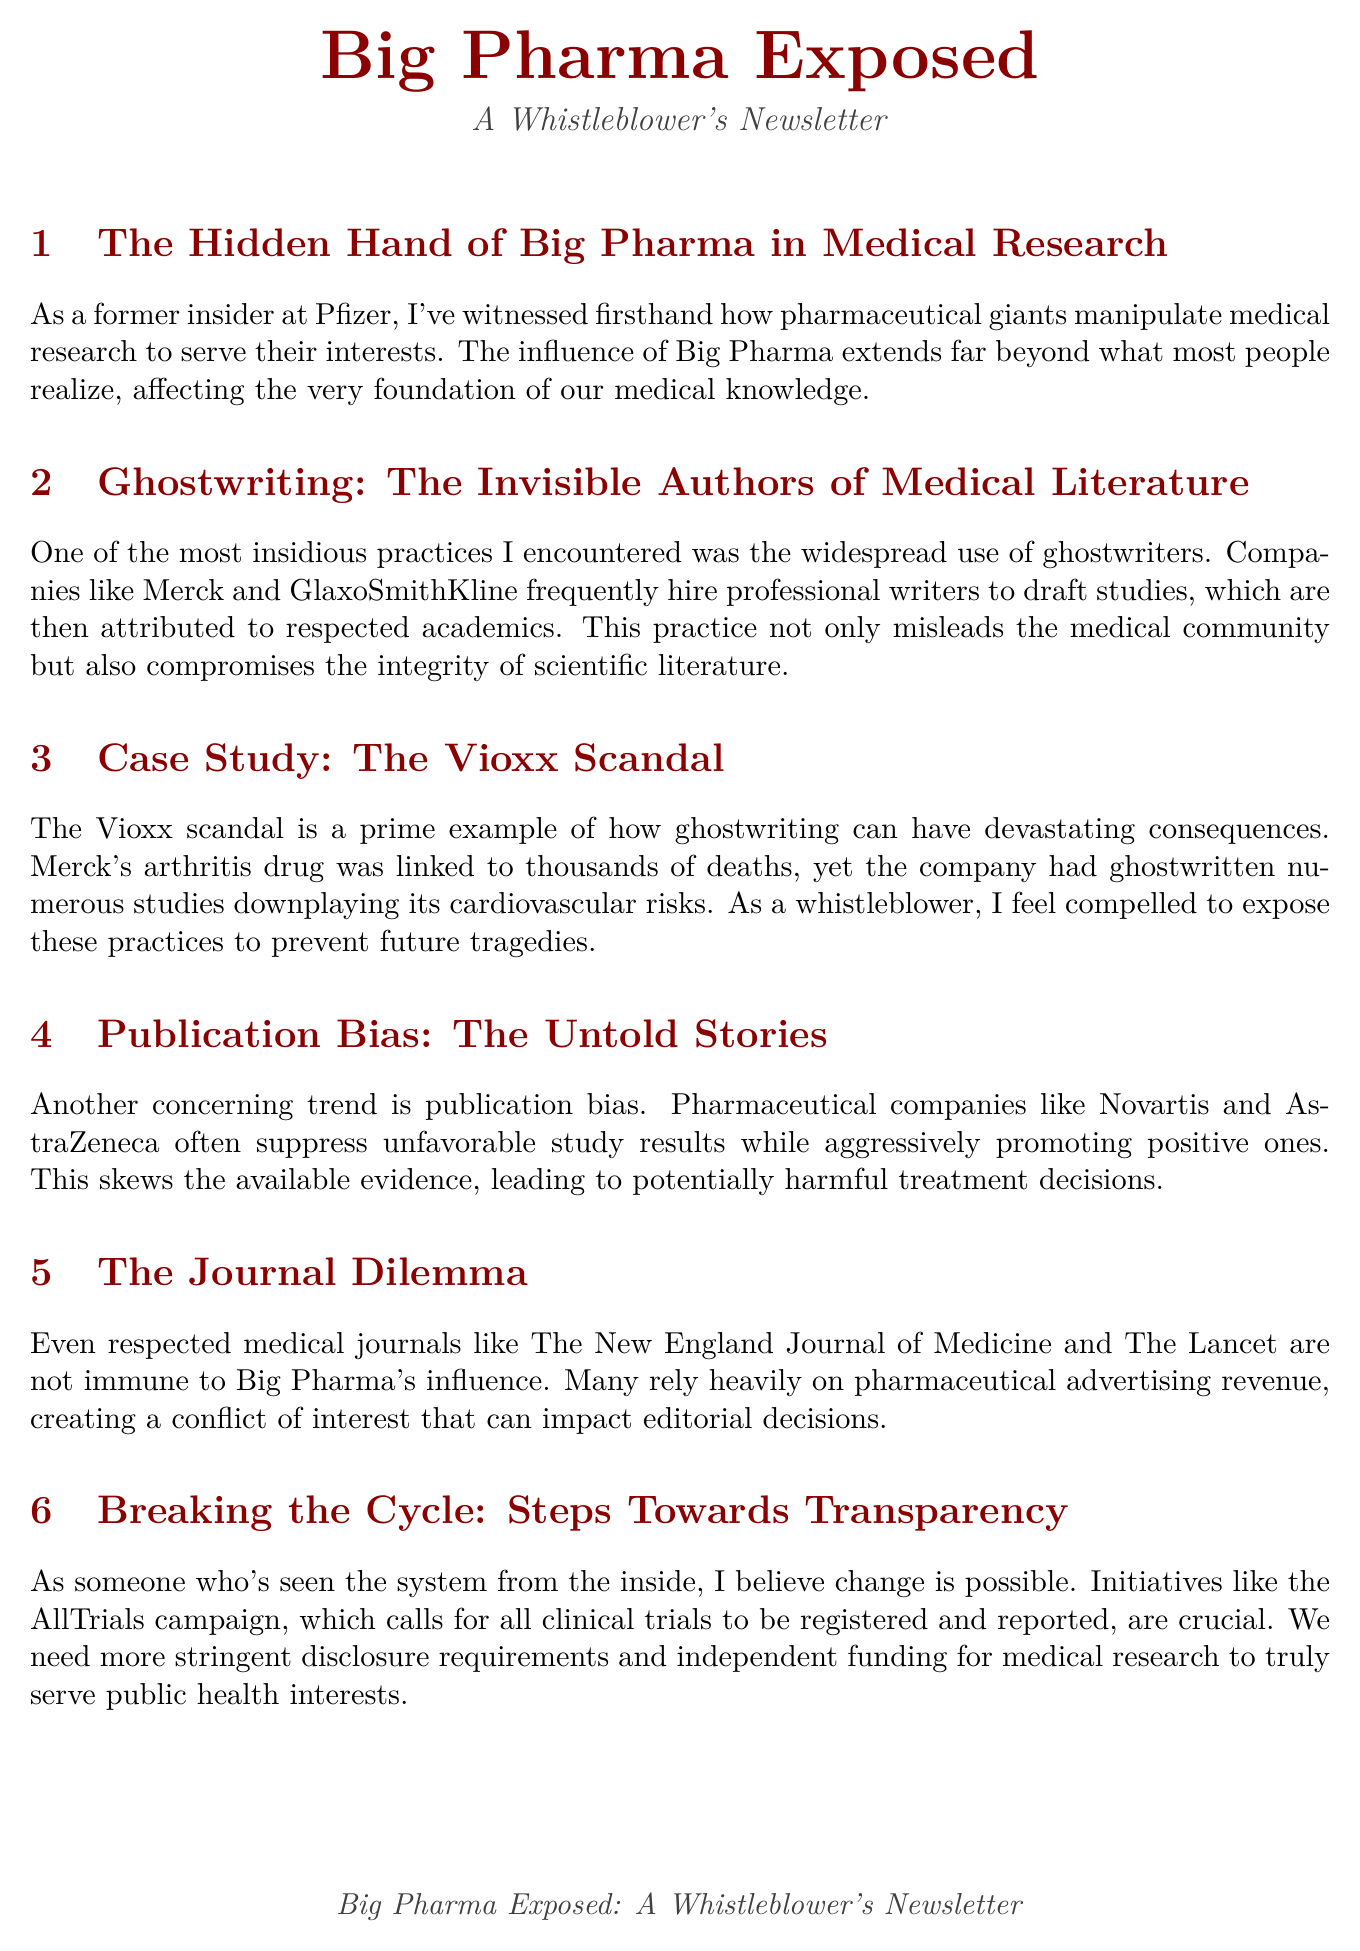What is the title of the newsletter? The title of the newsletter is stated at the beginning of the document and is "Big Pharma Exposed."
Answer: Big Pharma Exposed Who was the insider at Pfizer? The individual sharing their experience in the newsletter identifies themselves as a former insider at Pfizer.
Answer: A former insider at Pfizer Which pharmaceutical company was involved in the Vioxx scandal? The Vioxx scandal specifically mentions a pharmaceutical company known for its arthritis drug.
Answer: Merck What campaign calls for all clinical trials to be registered and reported? The document refers to an initiative that emphasizes the registration and reporting of clinical trials.
Answer: AllTrials campaign Which two organizations are mentioned in relation to the role of regulatory bodies? The document discusses the roles of specific regulatory bodies responsible for overseeing medical practices.
Answer: FDA and EMA What practice compromises the integrity of scientific literature? The newsletter describes a practice involving the use of professional writers who are not credited in medical studies.
Answer: Ghostwriting What trend skews available evidence leading to harmful treatment decisions? The text addresses a particular trend where negative study results are not made public.
Answer: Publication bias Which respected journal is mentioned as being influenced by pharmaceutical advertising revenue? The newsletter highlights a reputable journal that may have conflicts of interest due to funding.
Answer: The New England Journal of Medicine 